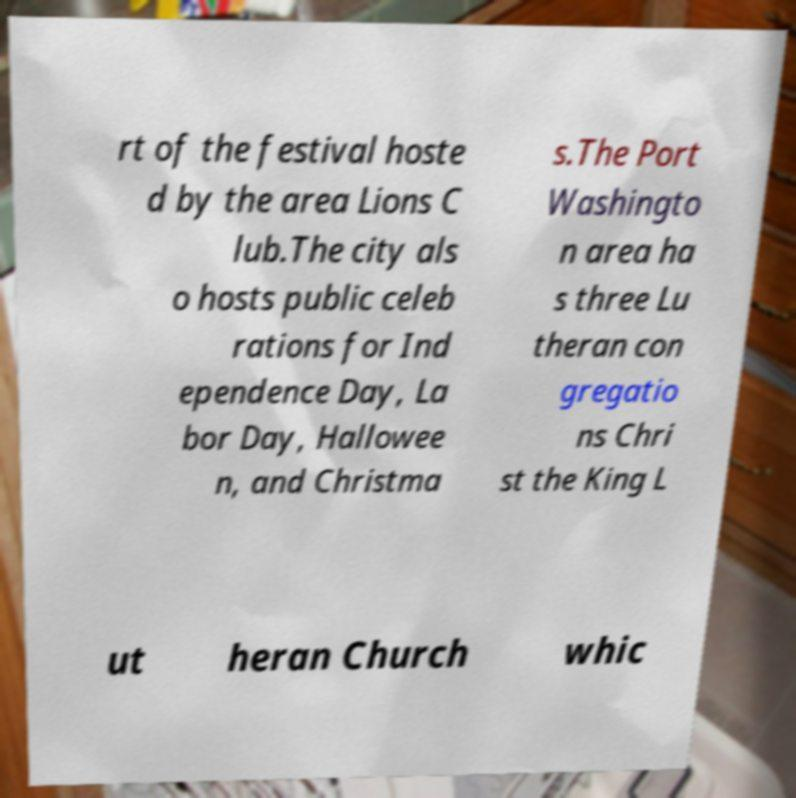There's text embedded in this image that I need extracted. Can you transcribe it verbatim? rt of the festival hoste d by the area Lions C lub.The city als o hosts public celeb rations for Ind ependence Day, La bor Day, Hallowee n, and Christma s.The Port Washingto n area ha s three Lu theran con gregatio ns Chri st the King L ut heran Church whic 